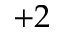<formula> <loc_0><loc_0><loc_500><loc_500>+ 2</formula> 